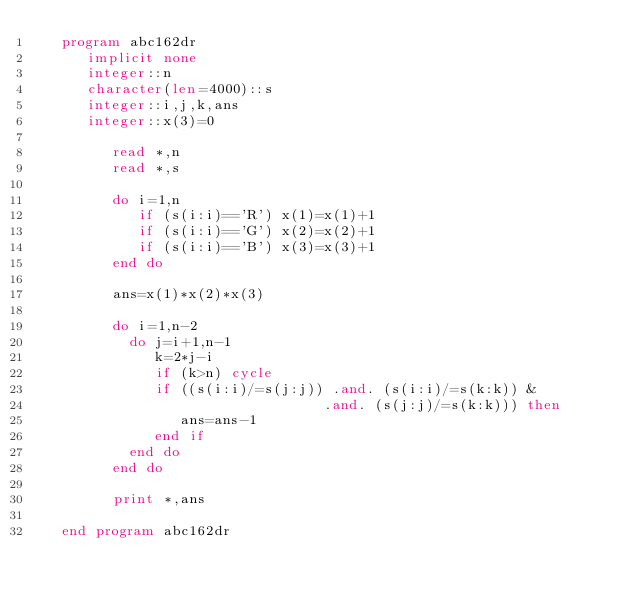<code> <loc_0><loc_0><loc_500><loc_500><_FORTRAN_>   program abc162dr
      implicit none
      integer::n
      character(len=4000)::s
      integer::i,j,k,ans
      integer::x(3)=0

         read *,n
         read *,s

         do i=1,n
            if (s(i:i)=='R') x(1)=x(1)+1
            if (s(i:i)=='G') x(2)=x(2)+1
            if (s(i:i)=='B') x(3)=x(3)+1
         end do

         ans=x(1)*x(2)*x(3)

         do i=1,n-2
           do j=i+1,n-1
              k=2*j-i
              if (k>n) cycle
              if ((s(i:i)/=s(j:j)) .and. (s(i:i)/=s(k:k)) &
                                  .and. (s(j:j)/=s(k:k))) then
                 ans=ans-1
              end if
           end do
         end do

         print *,ans

   end program abc162dr</code> 